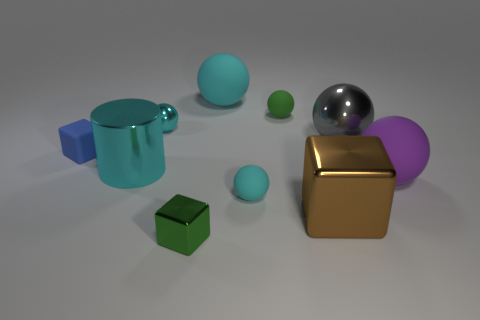Is the big metal cylinder the same color as the small metallic ball?
Ensure brevity in your answer.  Yes. How many large metallic objects are the same color as the small metal sphere?
Keep it short and to the point. 1. What is the material of the big thing in front of the rubber object to the right of the brown block?
Your response must be concise. Metal. How many objects are blocks that are to the left of the brown object or spheres in front of the big purple thing?
Offer a terse response. 3. What is the size of the metal object left of the small cyan sphere that is behind the big metallic thing to the left of the tiny metallic block?
Your answer should be compact. Large. Are there the same number of big metal things that are right of the gray object and small green spheres?
Provide a short and direct response. No. Are there any other things that have the same shape as the blue matte object?
Ensure brevity in your answer.  Yes. Is the shape of the big gray metal thing the same as the small green object behind the blue matte block?
Provide a succinct answer. Yes. There is a blue object that is the same shape as the big brown thing; what is its size?
Make the answer very short. Small. What number of other things are there of the same material as the big cyan cylinder
Offer a very short reply. 4. 